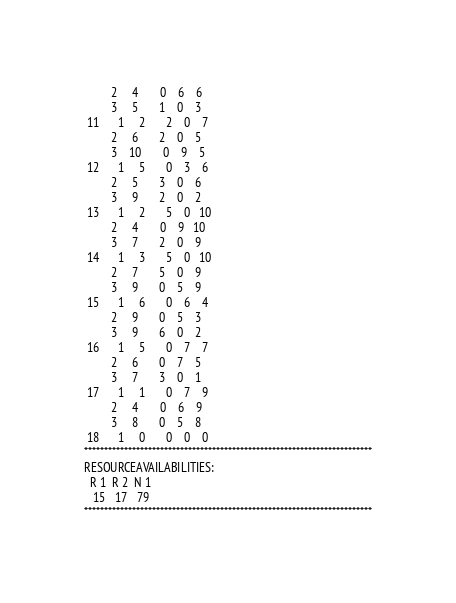<code> <loc_0><loc_0><loc_500><loc_500><_ObjectiveC_>         2     4       0    6    6
         3     5       1    0    3
 11      1     2       2    0    7
         2     6       2    0    5
         3    10       0    9    5
 12      1     5       0    3    6
         2     5       3    0    6
         3     9       2    0    2
 13      1     2       5    0   10
         2     4       0    9   10
         3     7       2    0    9
 14      1     3       5    0   10
         2     7       5    0    9
         3     9       0    5    9
 15      1     6       0    6    4
         2     9       0    5    3
         3     9       6    0    2
 16      1     5       0    7    7
         2     6       0    7    5
         3     7       3    0    1
 17      1     1       0    7    9
         2     4       0    6    9
         3     8       0    5    8
 18      1     0       0    0    0
************************************************************************
RESOURCEAVAILABILITIES:
  R 1  R 2  N 1
   15   17   79
************************************************************************
</code> 